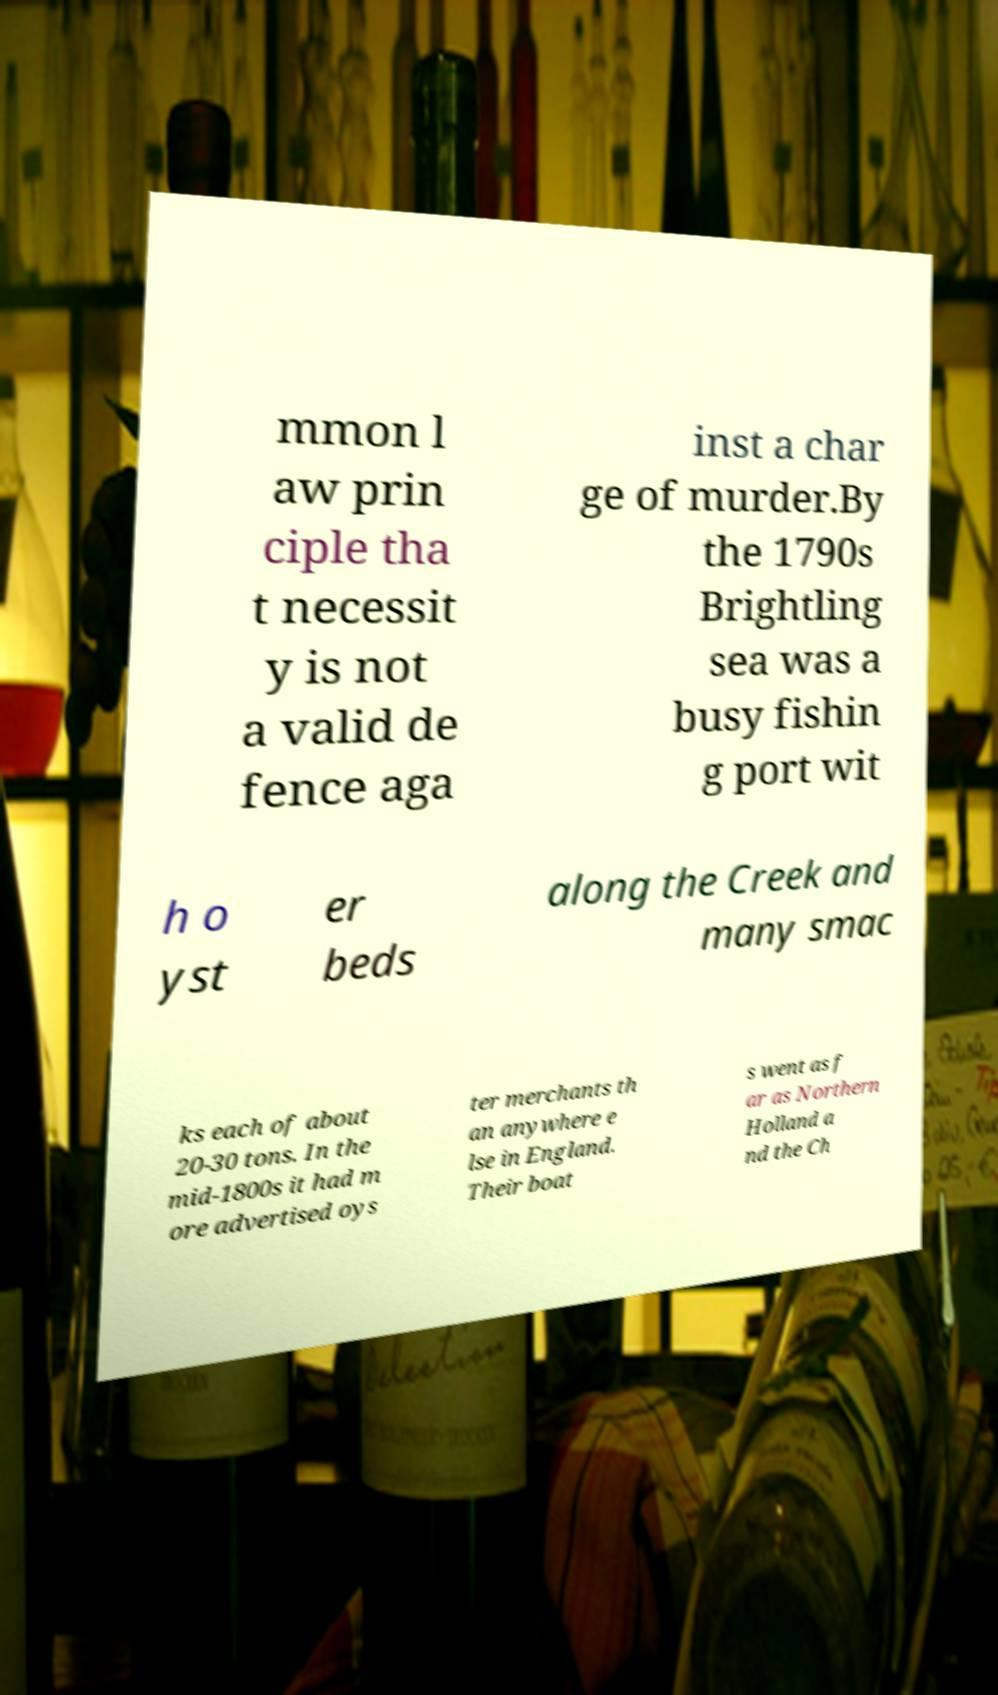For documentation purposes, I need the text within this image transcribed. Could you provide that? mmon l aw prin ciple tha t necessit y is not a valid de fence aga inst a char ge of murder.By the 1790s Brightling sea was a busy fishin g port wit h o yst er beds along the Creek and many smac ks each of about 20-30 tons. In the mid-1800s it had m ore advertised oys ter merchants th an anywhere e lse in England. Their boat s went as f ar as Northern Holland a nd the Ch 